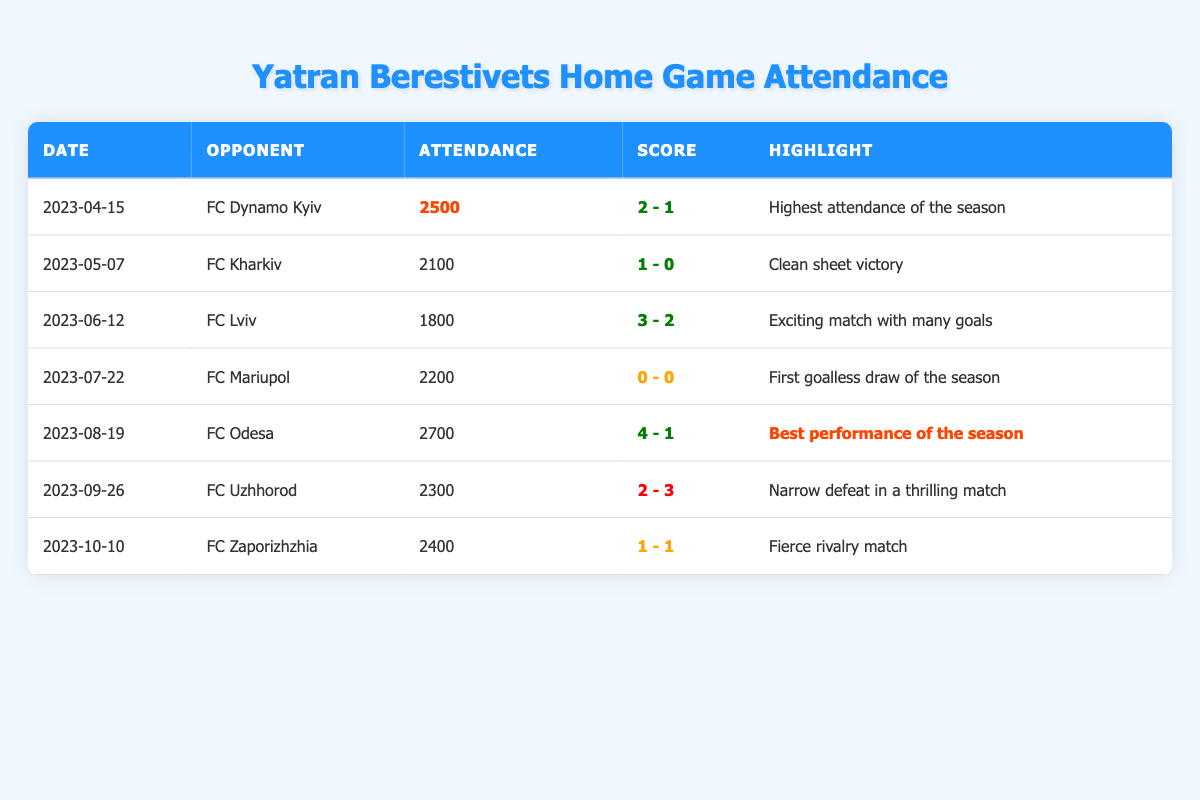What was the highest attendance at a Yatran Berestivets home game in the season? The table indicates the highest attendance was 2700 during the match against FC Odesa on August 19, 2023.
Answer: 2700 How many goals did Yatran Berestivets score on their best performance of the season? The best performance of the season, which had the highest attendance, was against FC Odesa where Yatran scored 4 goals.
Answer: 4 What was the total attendance for all home games? Adding up all the attendance figures: 2500 + 2100 + 1800 + 2200 + 2700 + 2300 + 2400 = 18500.
Answer: 18500 Did Yatran Berestivets have a clean sheet victory in the season? Yes, they won against FC Kharkiv on May 7, 2023, with a score of 1-0, which represents a clean sheet victory.
Answer: Yes Which match had the narrowest victory for Yatran Berestivets? The match against FC Uzhhorod had the narrowest victory, with Yatran scoring 2 goals but conceding 3, resulting in a loss.
Answer: Loss against FC Uzhhorod What is the average attendance for Yatran Berestivets home games? The total attendance is 18500, and there were 7 matches, so the average attendance is 18500 / 7 = 2642.86, which rounds to approximately 2643.
Answer: 2643 Which match had the most goals scored in total? The match against FC Lviv, where 5 goals were scored in total (3 by Yatran and 2 by Lviv).
Answer: 5 goals Which match was the first goalless draw of the season? The first goalless draw of the season was during the match against FC Mariupol on July 22, 2023.
Answer: FC Mariupol How many matches did Yatran Berestivets win at home? Yatran won 4 matches (against FC Dynamo Kyiv, FC Kharkiv, FC Lviv, and FC Odesa), while they lost 2 matches and drew 1.
Answer: 4 wins Was there a match where Yatran Berestivets had both the highest attendance and scored the most goals? Yes, the match against FC Odesa had the highest attendance (2700) and Yatran scored the most goals during this match (4 goals).
Answer: Yes 